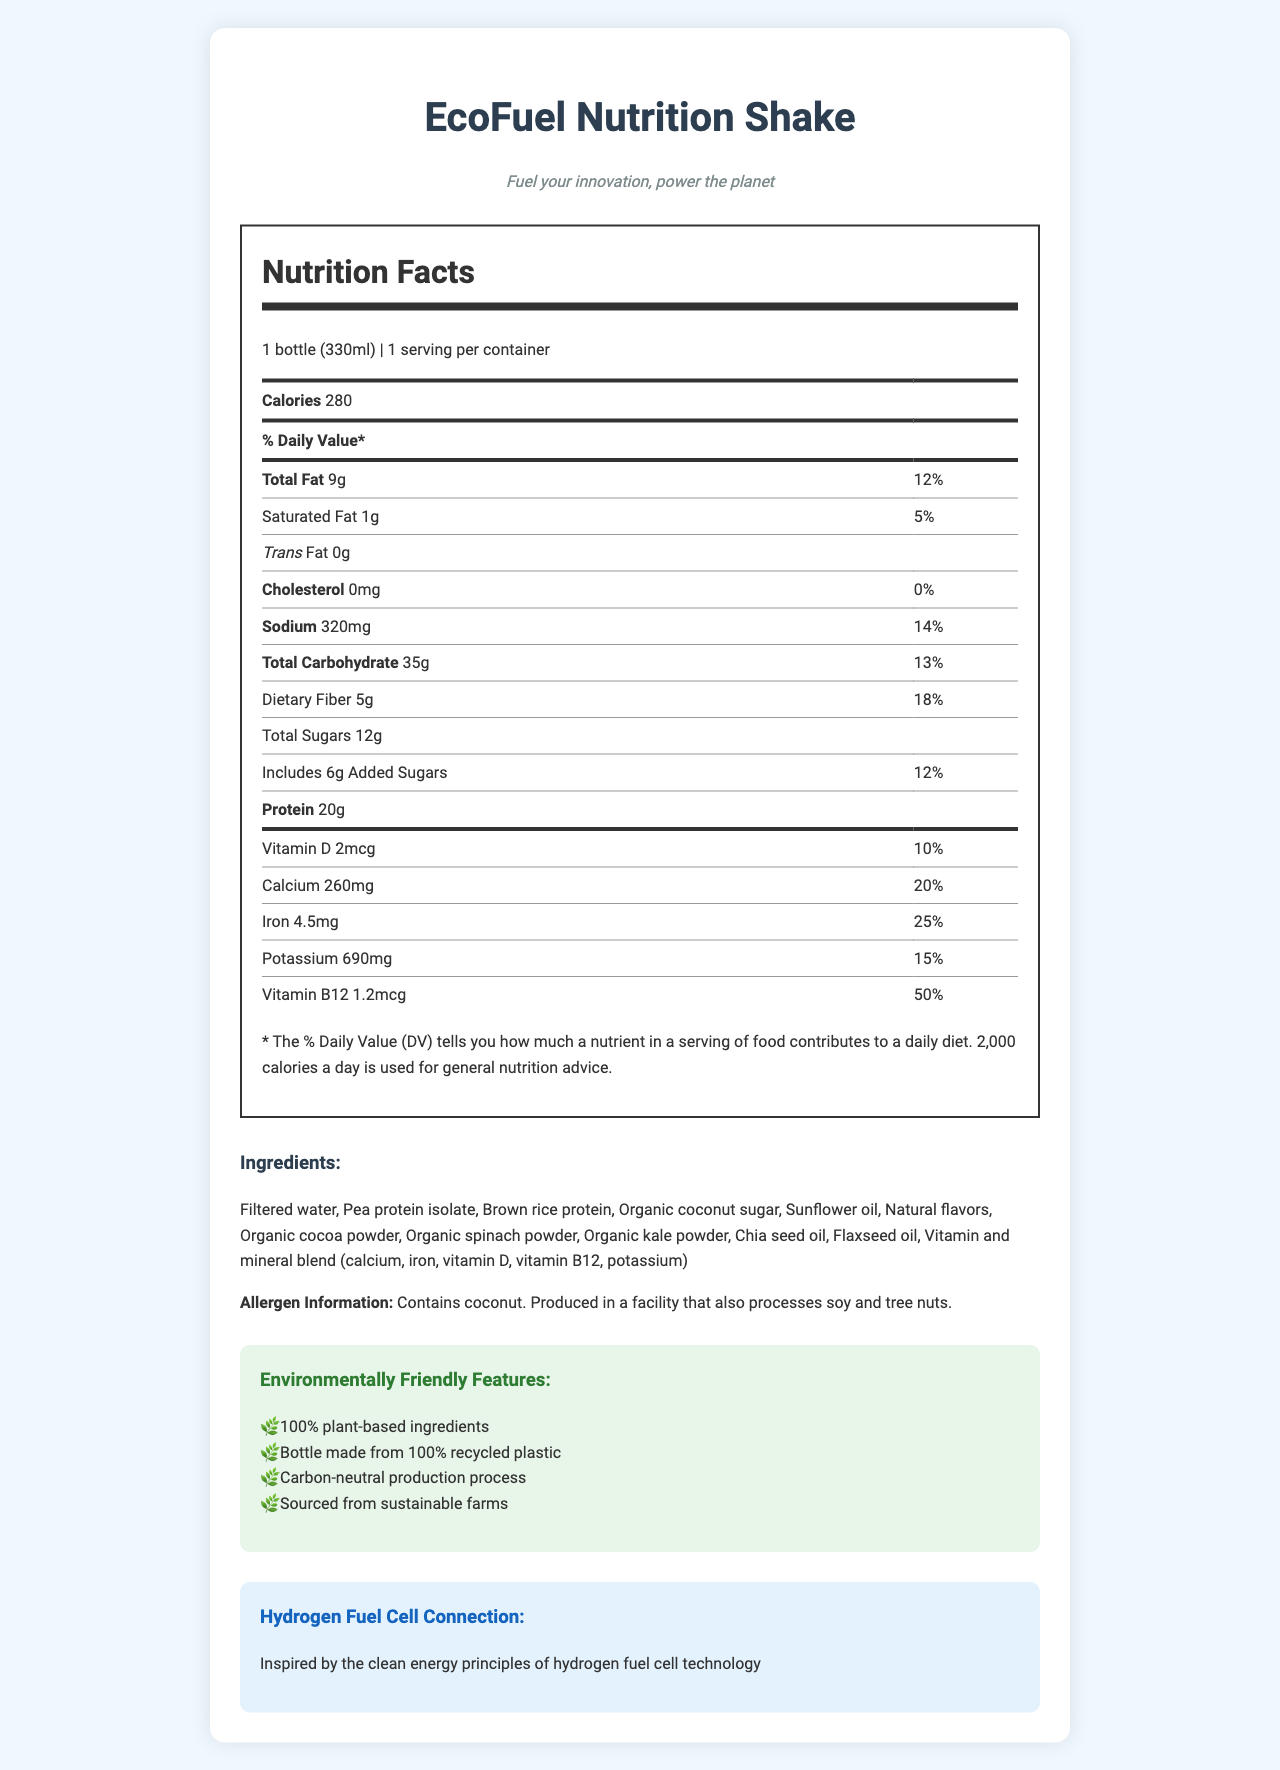what is the product name? The product name is clearly stated at the top of the document.
Answer: EcoFuel Nutrition Shake what is the serving size of the product? The serving size is mentioned under "Nutrition Facts" with the serving size and quantity.
Answer: 1 bottle (330ml) how many grams of dietary fiber does one serving contain? The document specifies "Dietary Fiber 5g" with a daily value percentage of 18%.
Answer: 5g is there any cholesterol in the EcoFuel Nutrition Shake? The document states "Cholesterol 0mg" with a daily value percentage of 0%.
Answer: No list two environmentally friendly features of the product. These features are listed under the "Environmentally Friendly Features" section.
Answer: 100% plant-based ingredients, Bottle made from 100% recycled plastic what vitamins are included in the EcoFuel Nutrition Shake? The document lists these vitamins in the nutrition facts section.
Answer: Vitamin D, Vitamin B12 which of the following is an ingredient in the EcoFuel Nutrition Shake? A. Whey Protein Concentrate B. Brown Rice Protein C. Soy Protein Isolate D. Artificial Sweeteners The ingredient list includes "Brown rice protein" but not the other options.
Answer: B what percentage of the daily value for calcium does one serving provide? A. 10% B. 15% C. 20% D. 25% The document states "Calcium 260mg 20%" in the nutritional information section.
Answer: C does the product contain any trans fat? The document lists "Trans Fat 0g."
Answer: No can people with a tree nut allergy safely consume this product? The allergen information states that it is produced in a facility that processes tree nuts.
Answer: No what is the main idea of the document? The document's titles and section headings cover the nutritional facts, ingredients, environmental benefits, and its target audience and inspiration.
Answer: The EcoFuel Nutrition Shake is a plant-based meal replacement designed for environmentally-conscious automotive engineers. It provides detailed nutritional information, a list of ingredients, and highlights the product's environmentally friendly features and its connection to hydrogen fuel cell principles. what other nutrients are included in the vitamin and mineral blend? The document only lists a vitamin and mineral blend without specific detail on any other nutrients included.
Answer: Not enough information what is the relation to hydrogen fuel cell technology mentioned in the document? This information is found in the "Hydrogen Fuel Cell Connection" section, stating the environmental inspiration.
Answer: Inspired by the clean energy principles of hydrogen fuel cell technology 